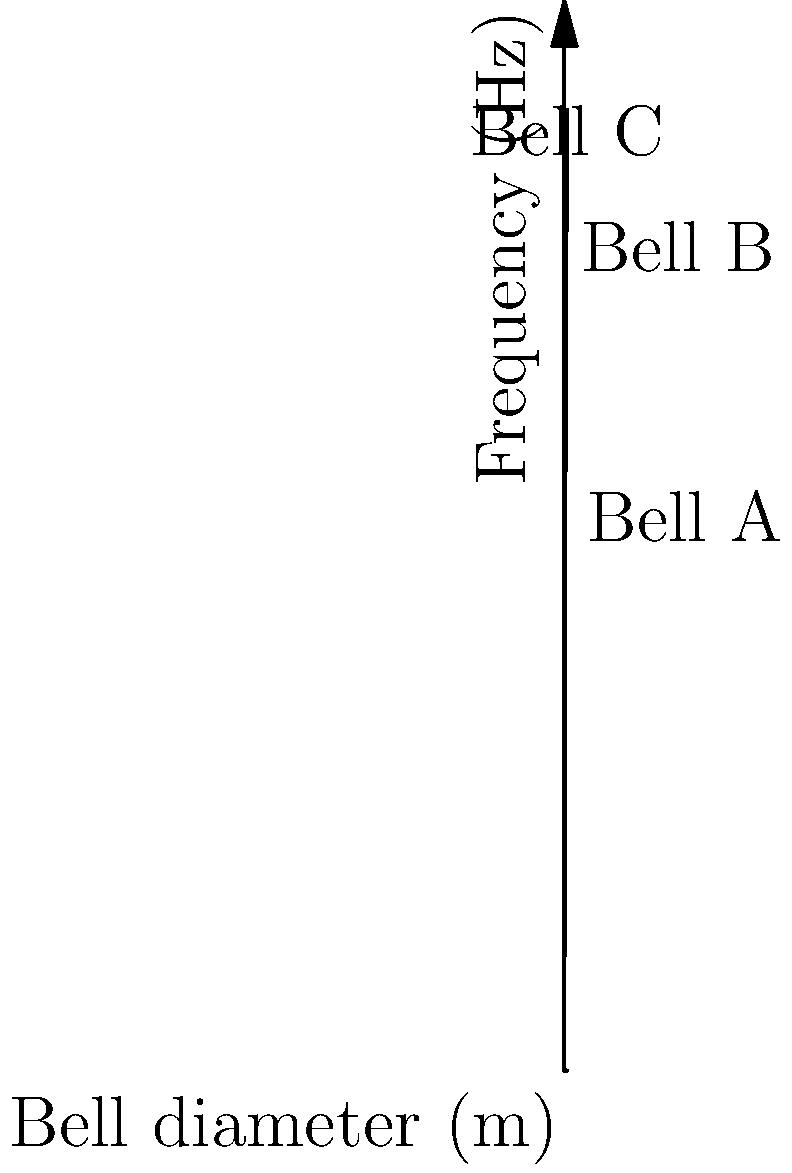A carillonneur has three bells made of the same bronze alloy but with different diameters. The relationship between the bell's diameter and its fundamental frequency can be approximated by the equation $f = 440\sqrt{d}$, where $f$ is the frequency in Hz and $d$ is the diameter in meters. Based on the graph, which bell would have a fundamental frequency closest to middle C (261.63 Hz)? To solve this problem, we need to follow these steps:

1. Understand the given equation: $f = 440\sqrt{d}$

2. Identify middle C frequency: 261.63 Hz

3. Analyze the graph:
   - Bell A: diameter ≈ 0.5 m
   - Bell B: diameter ≈ 1.0 m
   - Bell C: diameter ≈ 1.3 m

4. Calculate the frequency for each bell:
   - Bell A: $f_A = 440\sqrt{0.5} \approx 311$ Hz
   - Bell B: $f_B = 440\sqrt{1.0} = 440$ Hz
   - Bell C: $f_C = 440\sqrt{1.3} \approx 502$ Hz

5. Compare each frequency to middle C (261.63 Hz):
   - |311 - 261.63| ≈ 49.37 Hz
   - |440 - 261.63| ≈ 178.37 Hz
   - |502 - 261.63| ≈ 240.37 Hz

6. Determine the closest frequency to middle C

The frequency of Bell A (311 Hz) is closest to middle C (261.63 Hz).
Answer: Bell A 